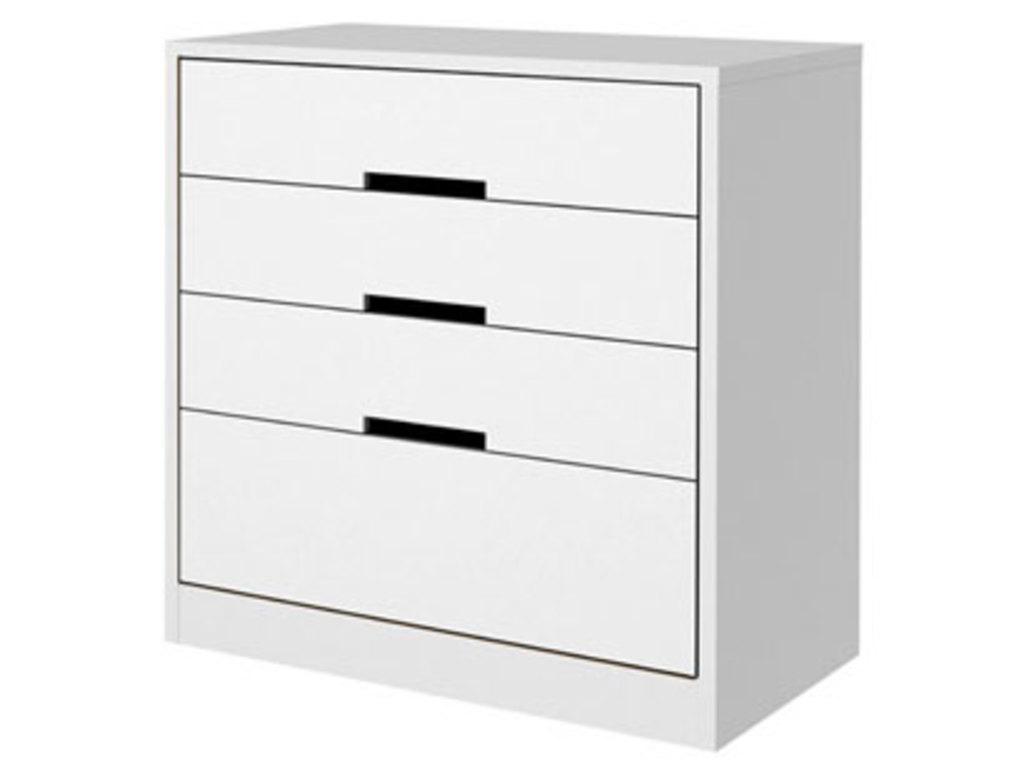How would you summarize this image in a sentence or two? We can see desk. In the background it is white. 